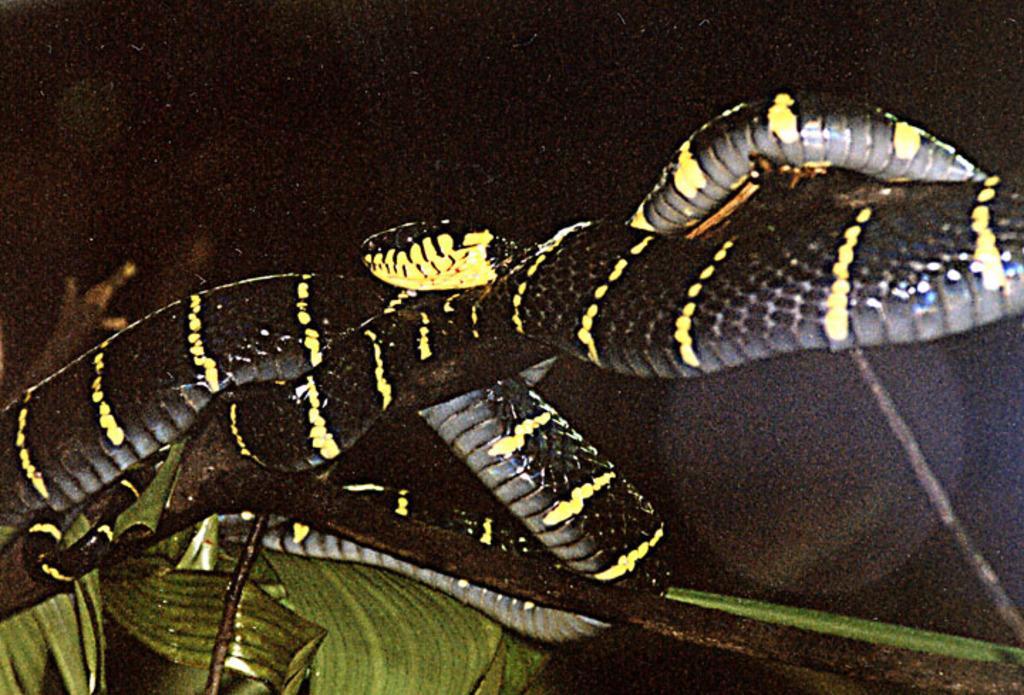How would you summarize this image in a sentence or two? In this picture we can see snake, branch and leaves. In the background of the image it is dark. 